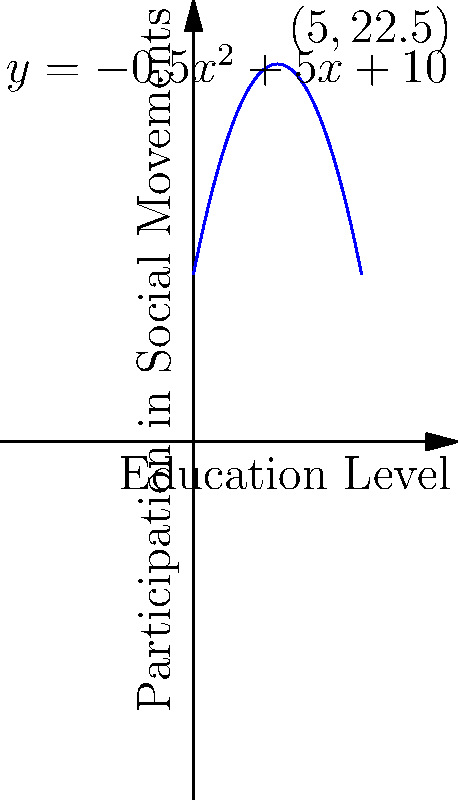The graph shows the relationship between education levels and participation in social movements in Morocco. If this relationship is modeled by the quadratic function $y = -0.5x^2 + 5x + 10$, where $x$ represents the education level and $y$ represents the participation level, at what education level is participation in social movements maximized? To find the education level where participation is maximized, we need to:

1. Recognize that the maximum of a quadratic function occurs at the vertex of the parabola.

2. For a quadratic function in the form $f(x) = ax^2 + bx + c$, the x-coordinate of the vertex is given by $x = -\frac{b}{2a}$.

3. In our function $y = -0.5x^2 + 5x + 10$:
   $a = -0.5$
   $b = 5$

4. Applying the formula:
   $x = -\frac{b}{2a} = -\frac{5}{2(-0.5)} = -\frac{5}{-1} = 5$

5. Therefore, the maximum participation occurs at an education level of 5.

6. We can verify this by observing that the vertex of the parabola in the graph is indeed at $x = 5$.
Answer: 5 